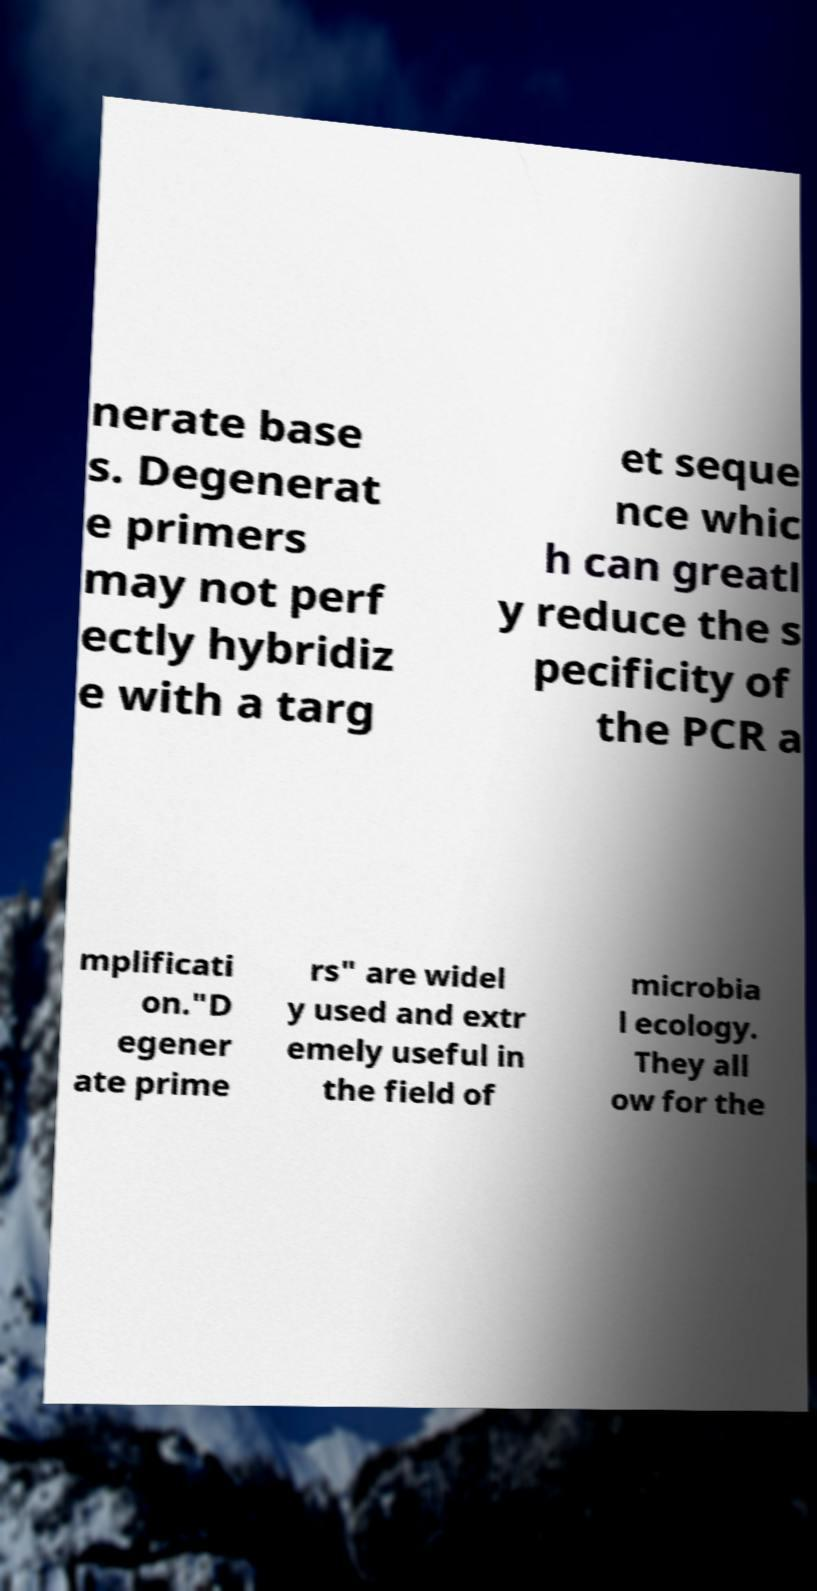For documentation purposes, I need the text within this image transcribed. Could you provide that? nerate base s. Degenerat e primers may not perf ectly hybridiz e with a targ et seque nce whic h can greatl y reduce the s pecificity of the PCR a mplificati on."D egener ate prime rs" are widel y used and extr emely useful in the field of microbia l ecology. They all ow for the 